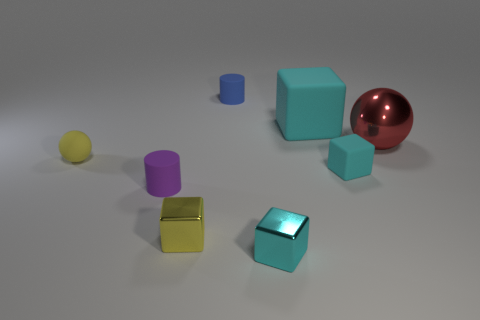Can you describe the largest object in the image? The largest object in the image is a sphere with a glossy, reflective surface that appears to be made of metal. It has a distinct red color that stands out among the other objects. 